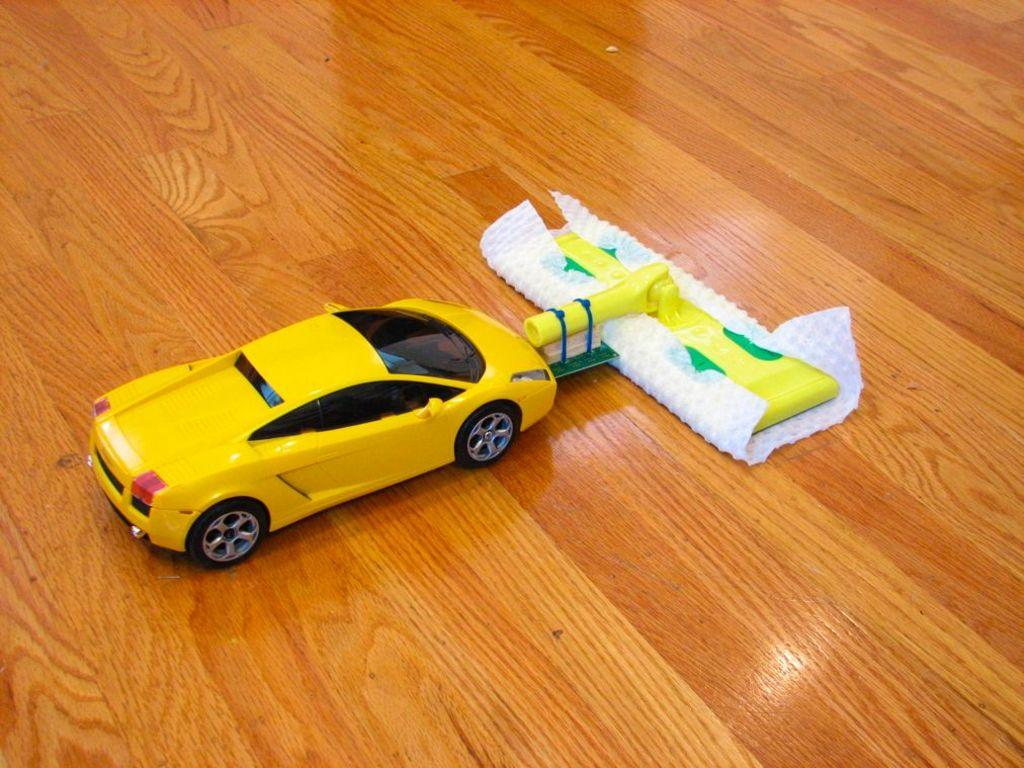What type of toy is visible in the image? There is a toy car in the image. Can you describe the object on the floor in the image? Unfortunately, the facts provided do not give any details about the object on the floor. What type of jar is visible on the toy car in the image? There is no jar present on the toy car in the image. What channel is the toy car tuned to in the image? The toy car is not a television or any device capable of receiving channels, so this question is not applicable. 